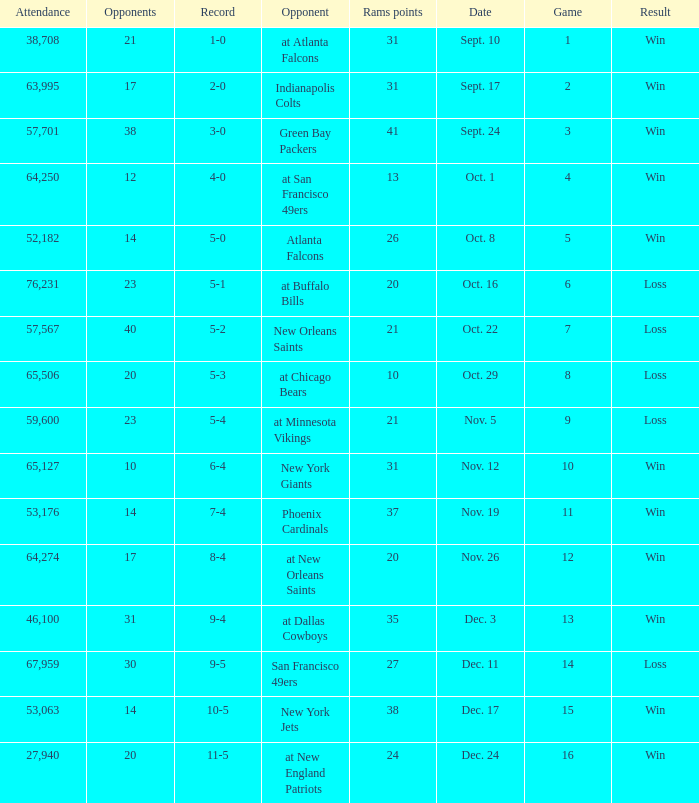What was the attendance where the record was 8-4? 64274.0. 